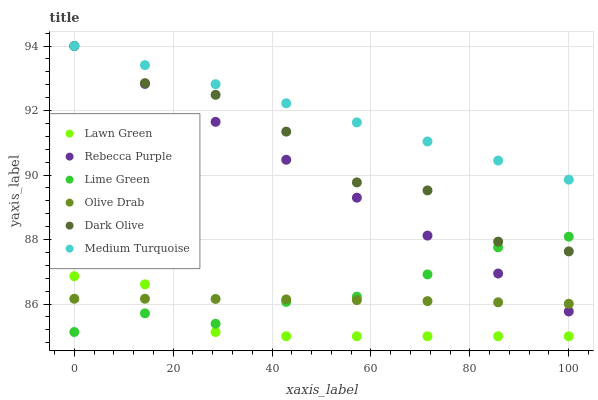Does Lawn Green have the minimum area under the curve?
Answer yes or no. Yes. Does Medium Turquoise have the maximum area under the curve?
Answer yes or no. Yes. Does Dark Olive have the minimum area under the curve?
Answer yes or no. No. Does Dark Olive have the maximum area under the curve?
Answer yes or no. No. Is Rebecca Purple the smoothest?
Answer yes or no. Yes. Is Dark Olive the roughest?
Answer yes or no. Yes. Is Dark Olive the smoothest?
Answer yes or no. No. Is Rebecca Purple the roughest?
Answer yes or no. No. Does Lawn Green have the lowest value?
Answer yes or no. Yes. Does Dark Olive have the lowest value?
Answer yes or no. No. Does Medium Turquoise have the highest value?
Answer yes or no. Yes. Does Lime Green have the highest value?
Answer yes or no. No. Is Lawn Green less than Rebecca Purple?
Answer yes or no. Yes. Is Rebecca Purple greater than Lawn Green?
Answer yes or no. Yes. Does Dark Olive intersect Rebecca Purple?
Answer yes or no. Yes. Is Dark Olive less than Rebecca Purple?
Answer yes or no. No. Is Dark Olive greater than Rebecca Purple?
Answer yes or no. No. Does Lawn Green intersect Rebecca Purple?
Answer yes or no. No. 